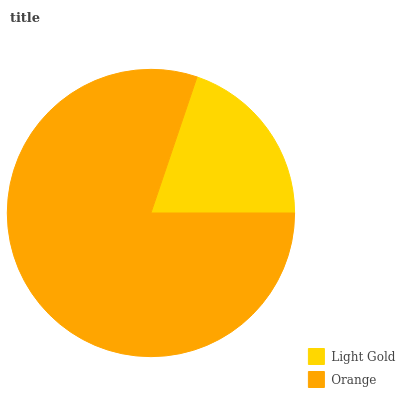Is Light Gold the minimum?
Answer yes or no. Yes. Is Orange the maximum?
Answer yes or no. Yes. Is Orange the minimum?
Answer yes or no. No. Is Orange greater than Light Gold?
Answer yes or no. Yes. Is Light Gold less than Orange?
Answer yes or no. Yes. Is Light Gold greater than Orange?
Answer yes or no. No. Is Orange less than Light Gold?
Answer yes or no. No. Is Orange the high median?
Answer yes or no. Yes. Is Light Gold the low median?
Answer yes or no. Yes. Is Light Gold the high median?
Answer yes or no. No. Is Orange the low median?
Answer yes or no. No. 